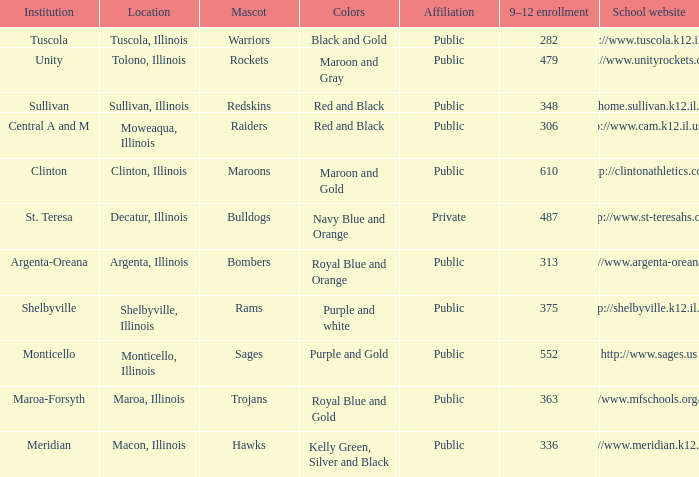What are the team colors from Tolono, Illinois? Maroon and Gray. 